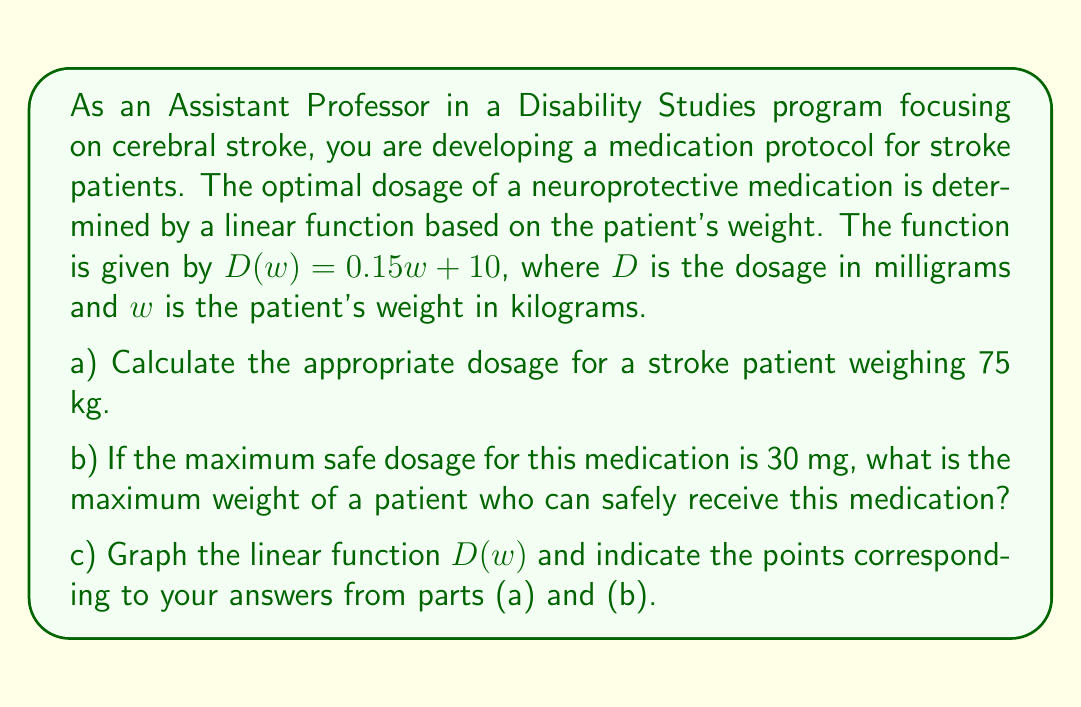Provide a solution to this math problem. Let's approach this problem step by step:

a) To find the dosage for a 75 kg patient, we substitute $w = 75$ into the given function:

   $D(75) = 0.15(75) + 10$
   $D(75) = 11.25 + 10 = 21.25$ mg

b) To find the maximum weight, we need to solve the equation:
   
   $30 = 0.15w + 10$
   $20 = 0.15w$
   $w = 20 / 0.15 = 133.33$ kg

c) To graph the function, we'll use Asymptote:

[asy]
import graph;
size(200,200);
real f(real x) {return 0.15x + 10;}
xaxis("Weight (kg)", Arrow);
yaxis("Dosage (mg)", Arrow);
draw(graph(f,0,150));
dot((75,21.25));
dot((133.33,30));
label("(75, 21.25)", (75,21.25), E);
label("(133.33, 30)", (133.33,30), E);
[/asy]

The graph shows the linear relationship between weight and dosage. The point (75, 21.25) corresponds to the answer from part (a), and the point (133.33, 30) corresponds to the answer from part (b).
Answer: a) 21.25 mg
b) 133.33 kg
c) Graph shown with points (75, 21.25) and (133.33, 30) indicated. 